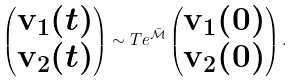Convert formula to latex. <formula><loc_0><loc_0><loc_500><loc_500>\begin{pmatrix} { \mathbf v } _ { 1 } ( t ) \\ { \mathbf v } _ { 2 } ( t ) \end{pmatrix} \sim T e ^ { \bar { \mathcal { M } } } \begin{pmatrix} { \mathbf v } _ { 1 } ( 0 ) \\ { \mathbf v } _ { 2 } ( 0 ) \end{pmatrix} .</formula> 